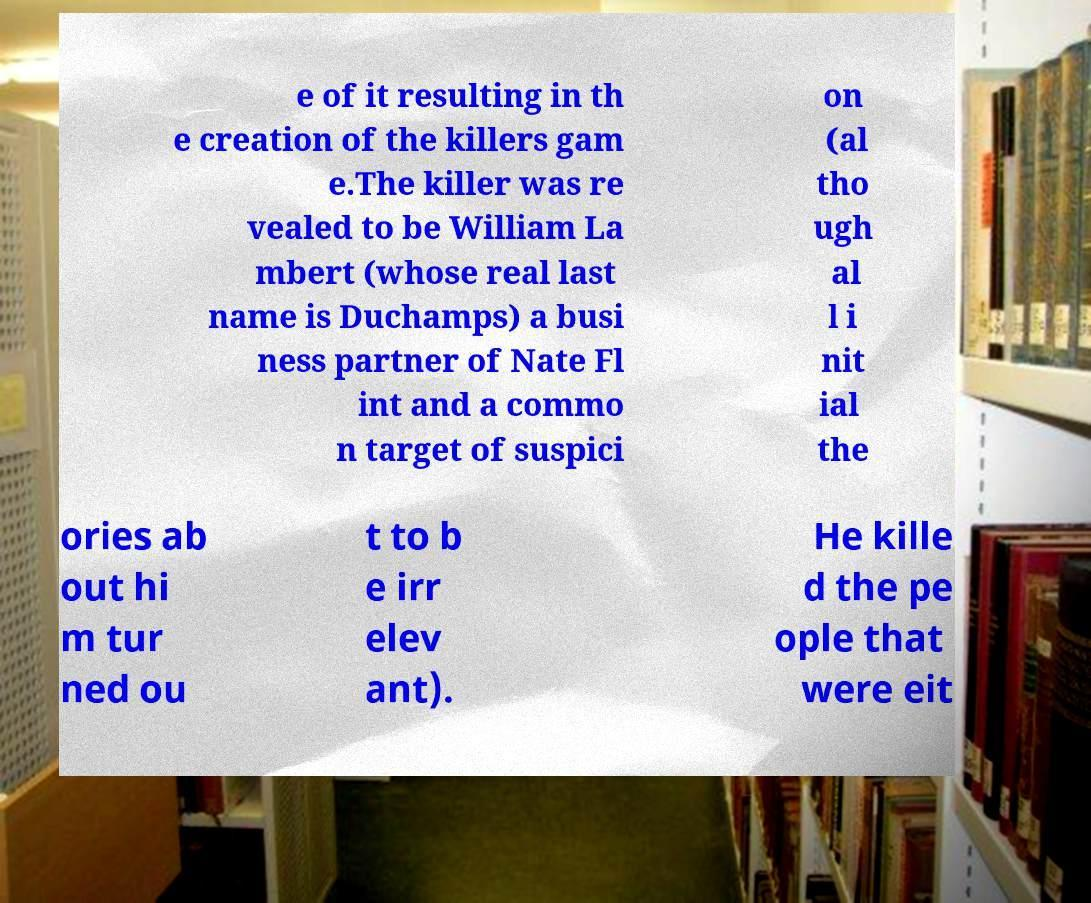Can you read and provide the text displayed in the image?This photo seems to have some interesting text. Can you extract and type it out for me? e of it resulting in th e creation of the killers gam e.The killer was re vealed to be William La mbert (whose real last name is Duchamps) a busi ness partner of Nate Fl int and a commo n target of suspici on (al tho ugh al l i nit ial the ories ab out hi m tur ned ou t to b e irr elev ant). He kille d the pe ople that were eit 